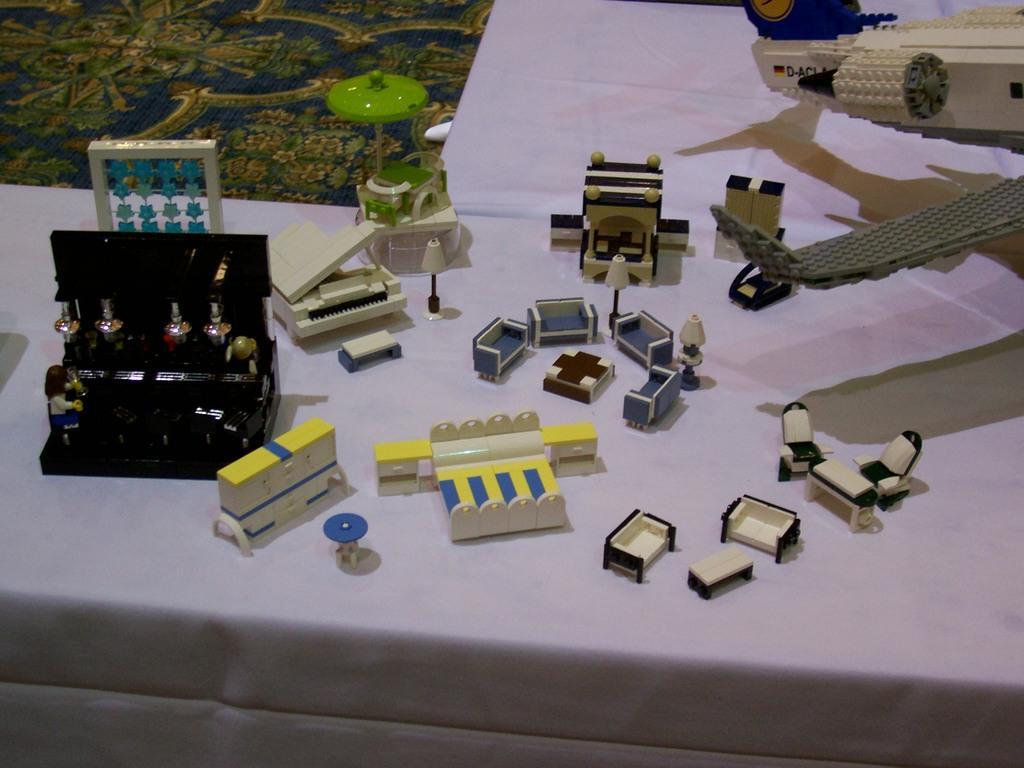How would you summarize this image in a sentence or two? In this image in the foreground there is one table, on the table there are some toys and building blocks. And in the background there is a carpet. 